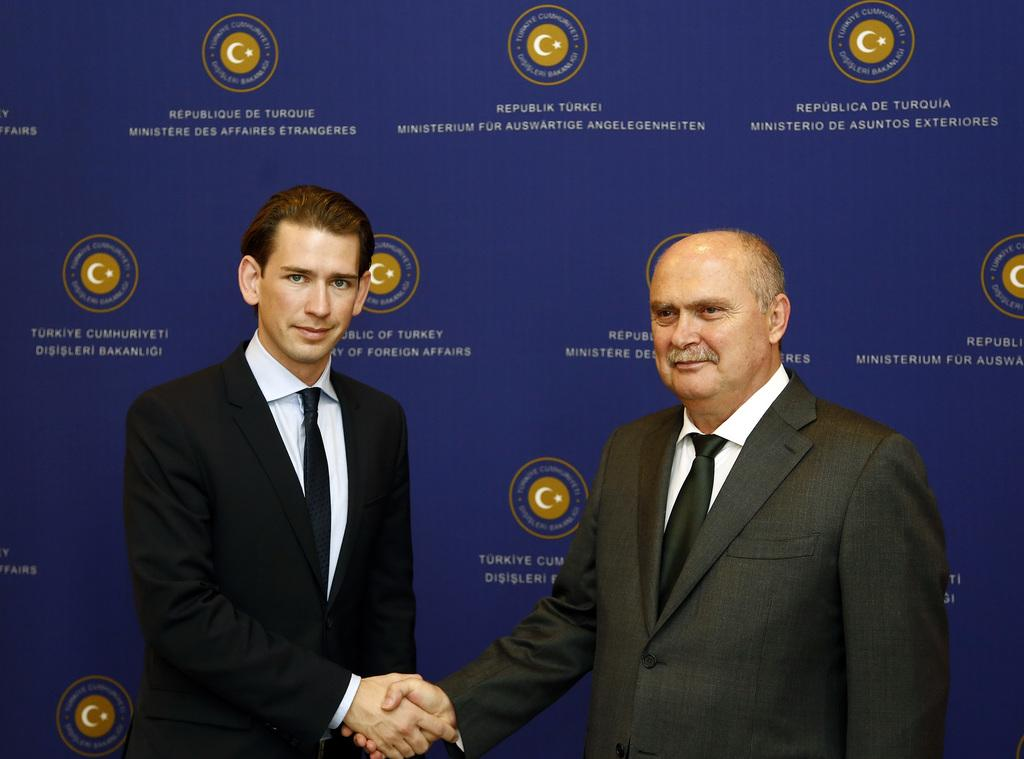How many people are in the image? There are two persons standing in the image. Can you describe the clothing of the person wearing a black coat? The person wearing a black coat is also wearing a black tie. What color is the coat worn by the other person? The other person is wearing a grey coat. What type of silver train can be seen in the background of the image? There is no train, silver or otherwise, present in the image. 